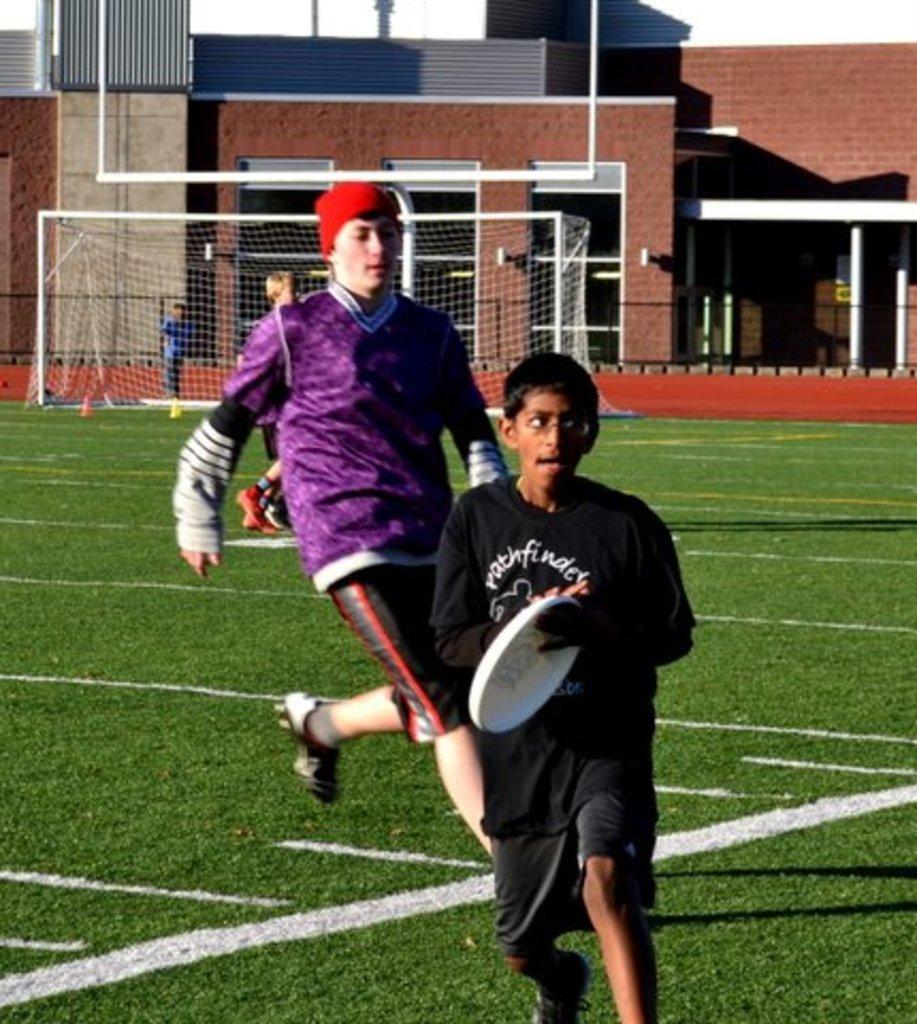Describe this image in one or two sentences. This image is taken in a stadium. In the center there are persons playing. In the background there is a net and there is a building which is red in colour. On the ground there is grass. 